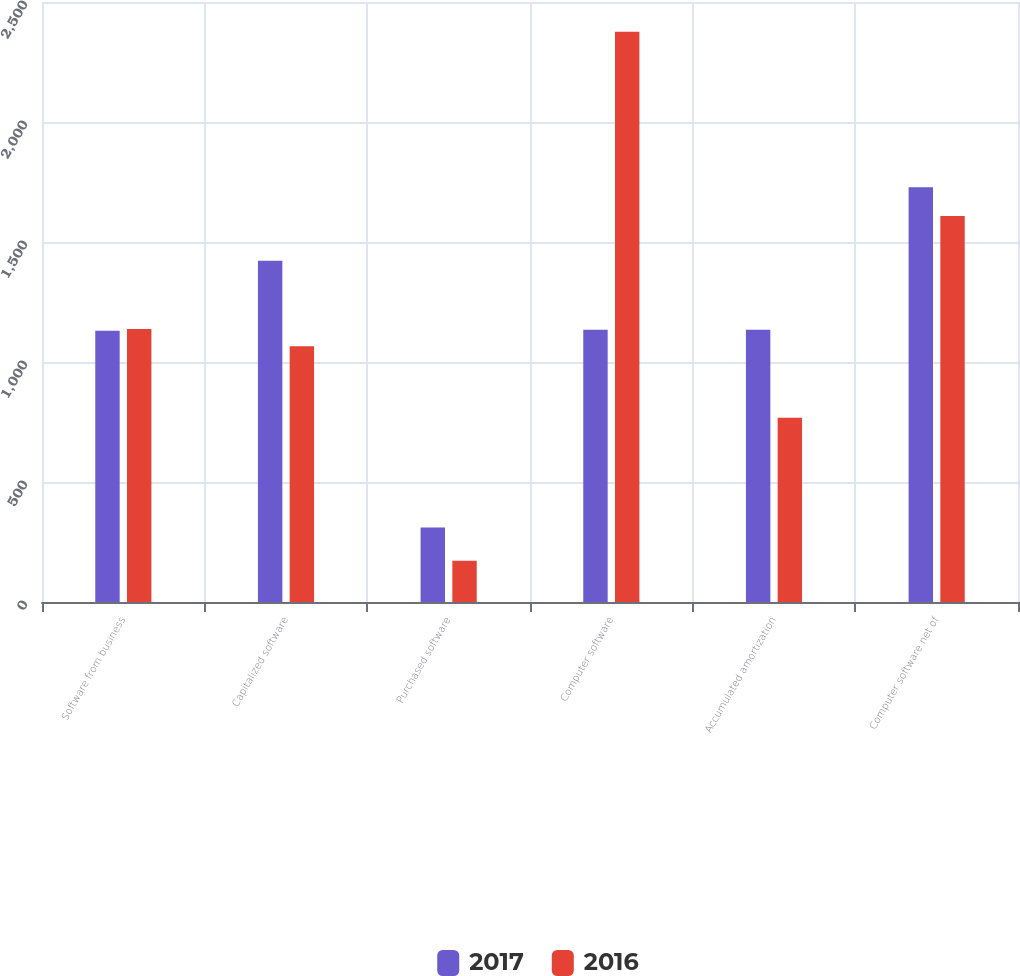Convert chart. <chart><loc_0><loc_0><loc_500><loc_500><stacked_bar_chart><ecel><fcel>Software from business<fcel>Capitalized software<fcel>Purchased software<fcel>Computer software<fcel>Accumulated amortization<fcel>Computer software net of<nl><fcel>2017<fcel>1130<fcel>1422<fcel>310<fcel>1134<fcel>1134<fcel>1728<nl><fcel>2016<fcel>1138<fcel>1066<fcel>172<fcel>2376<fcel>768<fcel>1608<nl></chart> 